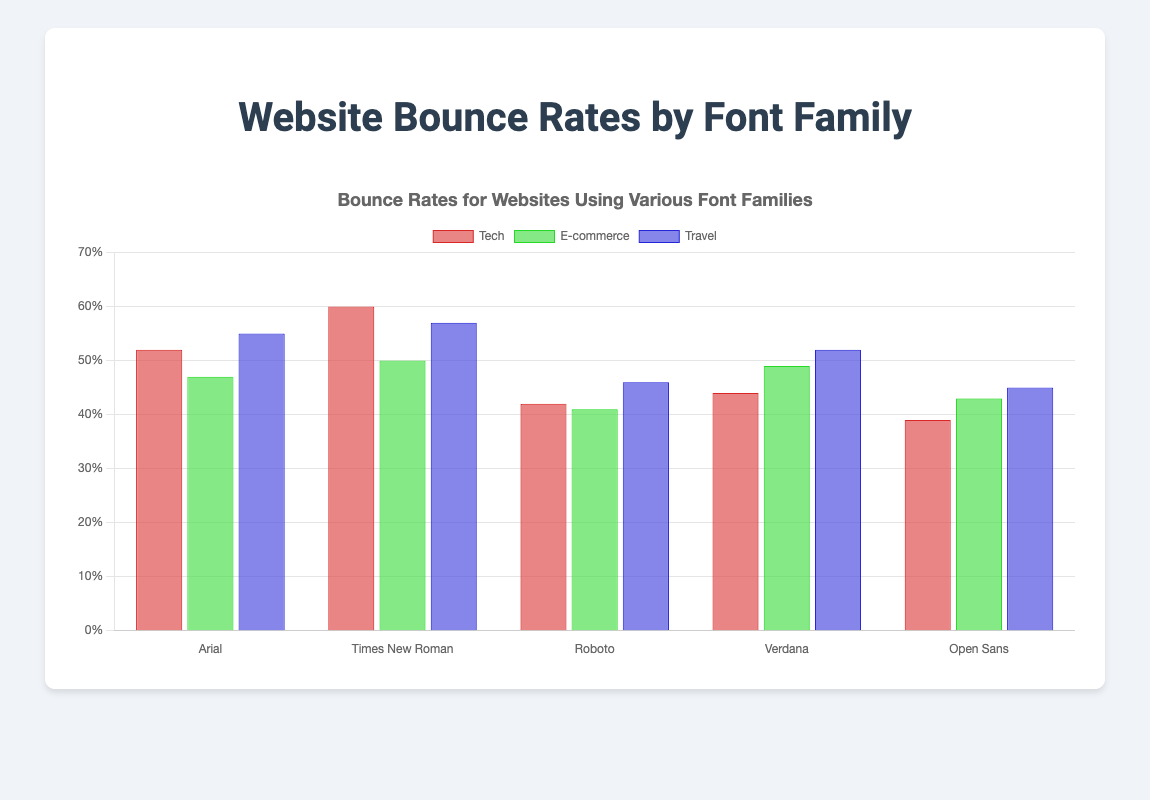What is the bounce rate for the Tech Blog using Arial font? Look at the bar corresponding to the Tech Blog under the Arial section; the bounce rate is 52%.
Answer: 52% Which website has the lowest bounce rate, and what font does it use? Compare the heights of all bars; the Corporate Website using Open Sans has the shortest bar, indicating the lowest bounce rate of 39%.
Answer: Corporate Website, Open Sans Among the websites using Verdana, which one has the highest bounce rate? In the Verdana group, compare the three bars; the Personal Blog has the highest bounce rate at 52%.
Answer: Personal Blog How does the bounce rate for the E-commerce Site compare to that of the University Portal? Find the bars for E-commerce Site under Arial and University Portal under Times New Roman; the bounce rate for the E-commerce Site is 47%, and for the University Portal, it is 50%.
Answer: E-commerce Site has a lower bounce rate What is the average bounce rate for the Tech Startup, Health & Fitness Blog, and Fashion Magazine, all using Roboto? Add bounce rates for Tech Startup (42%), Health & Fitness Blog (41%), and Fashion Magazine (46%); then divide by 3. (42% + 41% + 46%) / 3 = 43%.
Answer: 43% Which font family sees the highest average bounce rate across all its websites? Calculate the average bounce rate for each font family and compare: Arial (0.513), Times New Roman (0.556), Roboto (0.43), Verdana (0.483), Open Sans (0.423). Times New Roman has the highest average.
Answer: Times New Roman Is the bounce rate for the Cooking Blog closer to that of the Travel Blog or the Tech Blog? Compare the bounce rates: Cooking Blog (57%), Travel Blog (45%), Tech Blog (52%). The Cooking Blog's bounce rate is closest to that of the Tech Blog.
Answer: Tech Blog What is the difference in bounce rates between the Photography Portfolio and the News Website? Look at the bars for Photography Portfolio (49%) and News Website (60%); the difference is 60% - 49% = 11%.
Answer: 11% Which website within the Arial font family has the highest bounce rate? For the Arial font family, compare the bounce rates for Tech Blog (52%), E-commerce Site (47%), and Travel Agency (55%). The Travel Agency has the highest bounce rate.
Answer: Travel Agency What are the sum and average of the bounce rates for the websites using Open Sans font? Add bounce rates for Corporate Website (39%), Educational Blog (43%), and Travel Blog (45%); sum is 0.39 + 0.43 + 0.45 = 1.27, and the average is 1.27 / 3 = 0.423.
Answer: Sum: 1.27, Average: 42.3% 